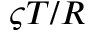Convert formula to latex. <formula><loc_0><loc_0><loc_500><loc_500>\varsigma T / R</formula> 